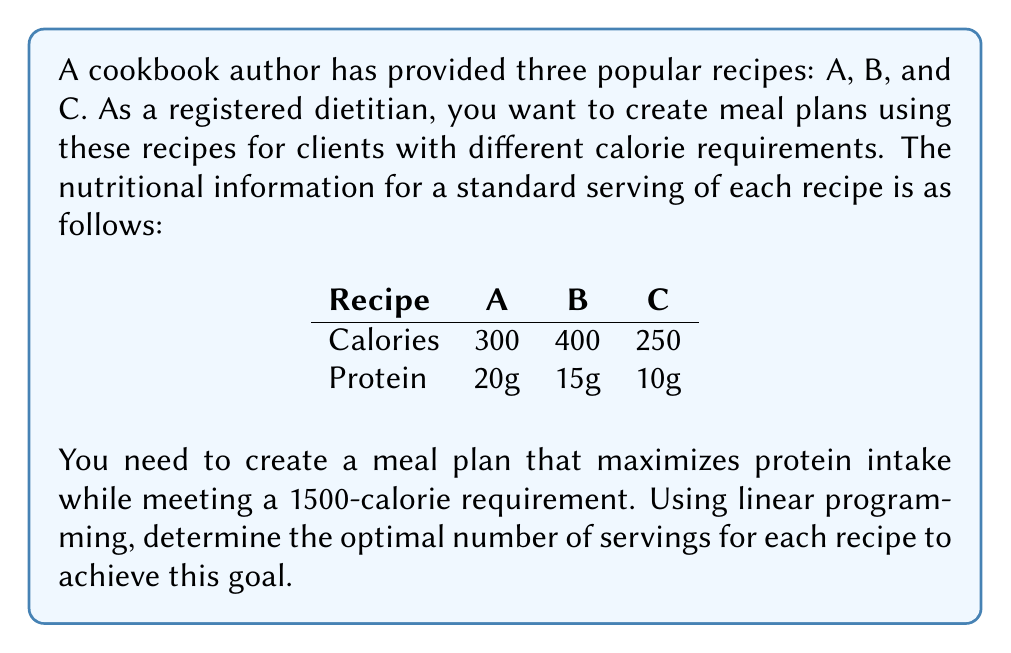Teach me how to tackle this problem. To solve this problem using linear programming, we need to set up the objective function and constraints.

Let $x$, $y$, and $z$ be the number of servings of Recipe A, B, and C, respectively.

Objective function (maximize protein):
$$\text{Maximize } P = 20x + 15y + 10z$$

Constraints:
1. Calorie requirement: $300x + 400y + 250z \leq 1500$
2. Non-negativity: $x \geq 0$, $y \geq 0$, $z \geq 0$

We can solve this using the simplex method or a linear programming solver. However, we can also reason through this problem:

1. Recipe A has the highest protein-to-calorie ratio (20g/300cal = 0.0667), followed by B (15g/400cal = 0.0375), then C (10g/250cal = 0.04).

2. To maximize protein, we should prioritize Recipe A.

3. The maximum number of servings of Recipe A that fits within 1500 calories is:
   $$1500 \div 300 = 5$$

4. Five servings of Recipe A provides:
   Calories: $5 \times 300 = 1500$
   Protein: $5 \times 20 = 100g$

5. This solution meets the calorie requirement exactly and maximizes protein intake.

Therefore, the optimal solution is 5 servings of Recipe A, 0 servings of Recipe B, and 0 servings of Recipe C.
Answer: Optimal servings:
Recipe A: 5
Recipe B: 0
Recipe C: 0
Maximum protein: 100g 